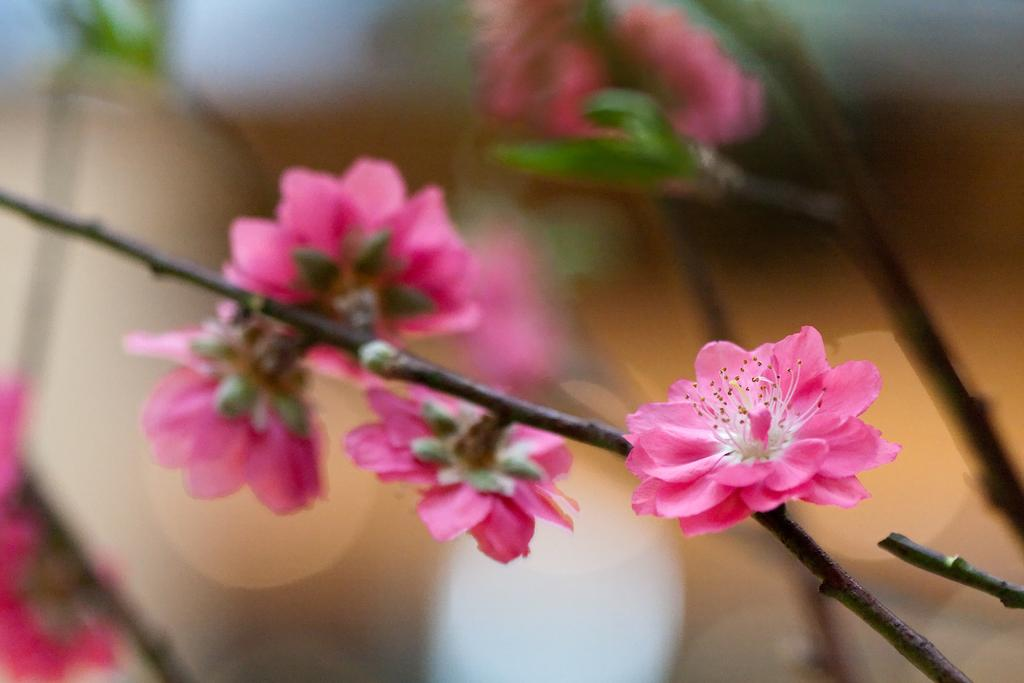What type of living organisms can be seen in the image? There are flowers in the image. Can you describe the background of the image? The background of the image is blurred. What type of trail can be seen in the image? There is no trail present in the image. What boundary separates the flowers from the background in the image? The image does not depict a boundary separating the flowers from the background. 